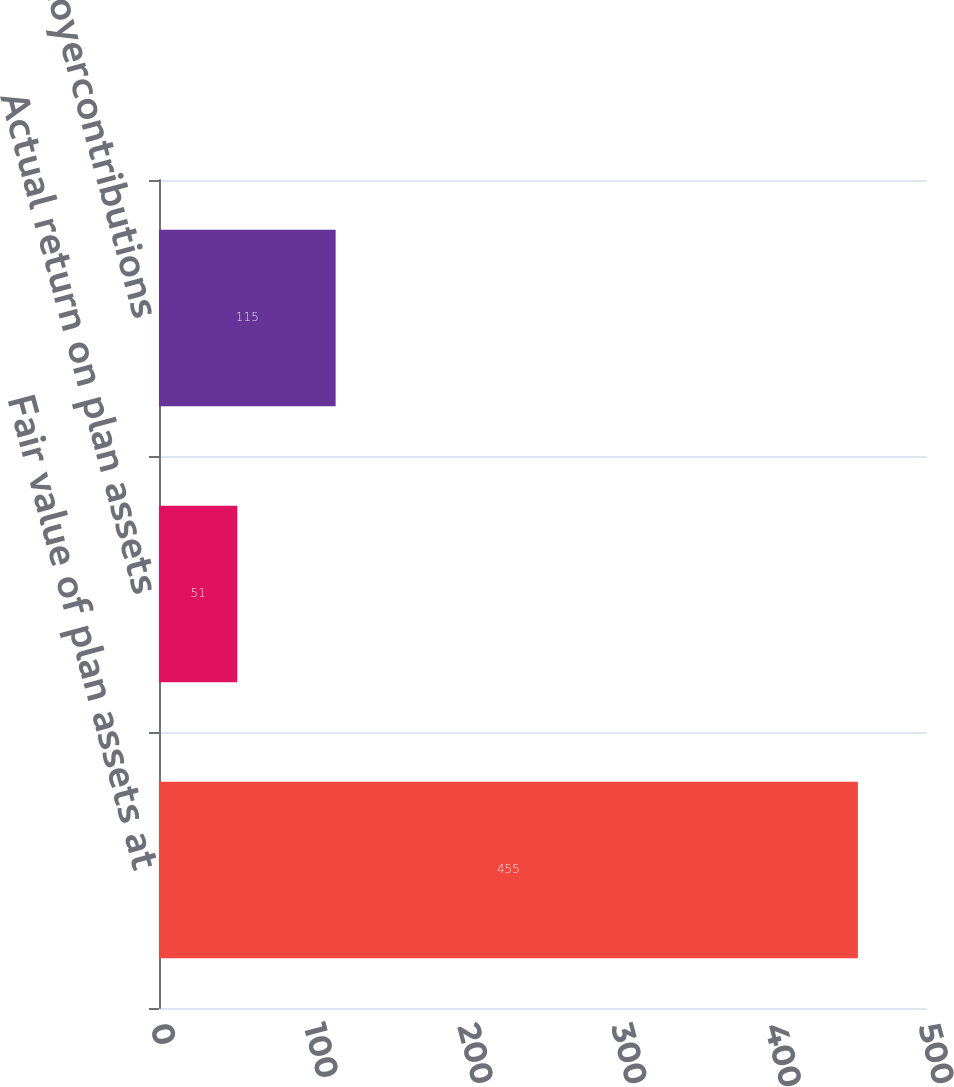<chart> <loc_0><loc_0><loc_500><loc_500><bar_chart><fcel>Fair value of plan assets at<fcel>Actual return on plan assets<fcel>Employercontributions<nl><fcel>455<fcel>51<fcel>115<nl></chart> 